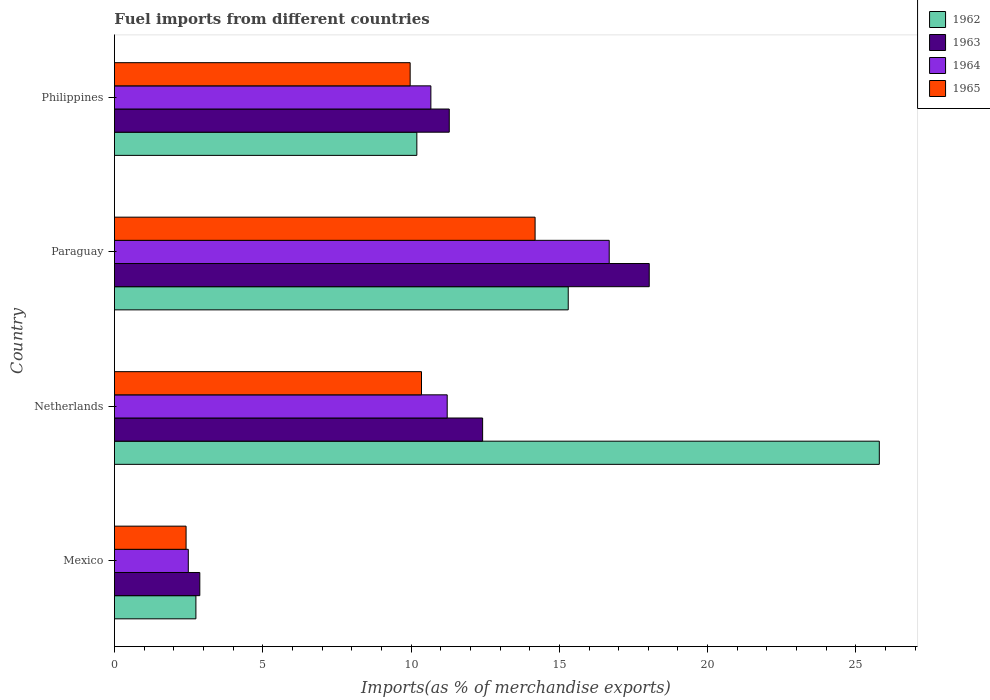Are the number of bars on each tick of the Y-axis equal?
Make the answer very short. Yes. How many bars are there on the 3rd tick from the bottom?
Provide a short and direct response. 4. What is the percentage of imports to different countries in 1965 in Philippines?
Offer a terse response. 9.97. Across all countries, what is the maximum percentage of imports to different countries in 1964?
Make the answer very short. 16.68. Across all countries, what is the minimum percentage of imports to different countries in 1962?
Your response must be concise. 2.75. In which country was the percentage of imports to different countries in 1964 maximum?
Offer a very short reply. Paraguay. In which country was the percentage of imports to different countries in 1962 minimum?
Provide a short and direct response. Mexico. What is the total percentage of imports to different countries in 1963 in the graph?
Your response must be concise. 44.61. What is the difference between the percentage of imports to different countries in 1965 in Netherlands and that in Paraguay?
Your answer should be compact. -3.83. What is the difference between the percentage of imports to different countries in 1964 in Paraguay and the percentage of imports to different countries in 1965 in Netherlands?
Give a very brief answer. 6.33. What is the average percentage of imports to different countries in 1963 per country?
Offer a very short reply. 11.15. What is the difference between the percentage of imports to different countries in 1965 and percentage of imports to different countries in 1962 in Philippines?
Give a very brief answer. -0.23. What is the ratio of the percentage of imports to different countries in 1965 in Paraguay to that in Philippines?
Provide a succinct answer. 1.42. Is the percentage of imports to different countries in 1965 in Mexico less than that in Paraguay?
Your response must be concise. Yes. Is the difference between the percentage of imports to different countries in 1965 in Paraguay and Philippines greater than the difference between the percentage of imports to different countries in 1962 in Paraguay and Philippines?
Provide a short and direct response. No. What is the difference between the highest and the second highest percentage of imports to different countries in 1963?
Your answer should be very brief. 5.62. What is the difference between the highest and the lowest percentage of imports to different countries in 1962?
Your response must be concise. 23.04. Is the sum of the percentage of imports to different countries in 1962 in Netherlands and Philippines greater than the maximum percentage of imports to different countries in 1965 across all countries?
Your answer should be very brief. Yes. What does the 1st bar from the bottom in Philippines represents?
Keep it short and to the point. 1962. How many bars are there?
Give a very brief answer. 16. How many countries are there in the graph?
Provide a short and direct response. 4. What is the difference between two consecutive major ticks on the X-axis?
Provide a short and direct response. 5. Are the values on the major ticks of X-axis written in scientific E-notation?
Keep it short and to the point. No. Does the graph contain any zero values?
Ensure brevity in your answer.  No. Where does the legend appear in the graph?
Provide a succinct answer. Top right. How many legend labels are there?
Offer a terse response. 4. How are the legend labels stacked?
Provide a succinct answer. Vertical. What is the title of the graph?
Ensure brevity in your answer.  Fuel imports from different countries. Does "1997" appear as one of the legend labels in the graph?
Make the answer very short. No. What is the label or title of the X-axis?
Give a very brief answer. Imports(as % of merchandise exports). What is the label or title of the Y-axis?
Your response must be concise. Country. What is the Imports(as % of merchandise exports) of 1962 in Mexico?
Provide a succinct answer. 2.75. What is the Imports(as % of merchandise exports) in 1963 in Mexico?
Provide a succinct answer. 2.88. What is the Imports(as % of merchandise exports) of 1964 in Mexico?
Your response must be concise. 2.49. What is the Imports(as % of merchandise exports) in 1965 in Mexico?
Provide a succinct answer. 2.42. What is the Imports(as % of merchandise exports) of 1962 in Netherlands?
Keep it short and to the point. 25.79. What is the Imports(as % of merchandise exports) in 1963 in Netherlands?
Provide a succinct answer. 12.41. What is the Imports(as % of merchandise exports) in 1964 in Netherlands?
Offer a very short reply. 11.22. What is the Imports(as % of merchandise exports) in 1965 in Netherlands?
Offer a very short reply. 10.35. What is the Imports(as % of merchandise exports) in 1962 in Paraguay?
Give a very brief answer. 15.3. What is the Imports(as % of merchandise exports) in 1963 in Paraguay?
Your answer should be very brief. 18.03. What is the Imports(as % of merchandise exports) in 1964 in Paraguay?
Your answer should be compact. 16.68. What is the Imports(as % of merchandise exports) of 1965 in Paraguay?
Provide a short and direct response. 14.18. What is the Imports(as % of merchandise exports) of 1962 in Philippines?
Ensure brevity in your answer.  10.2. What is the Imports(as % of merchandise exports) of 1963 in Philippines?
Keep it short and to the point. 11.29. What is the Imports(as % of merchandise exports) in 1964 in Philippines?
Keep it short and to the point. 10.67. What is the Imports(as % of merchandise exports) in 1965 in Philippines?
Keep it short and to the point. 9.97. Across all countries, what is the maximum Imports(as % of merchandise exports) in 1962?
Offer a very short reply. 25.79. Across all countries, what is the maximum Imports(as % of merchandise exports) of 1963?
Keep it short and to the point. 18.03. Across all countries, what is the maximum Imports(as % of merchandise exports) in 1964?
Offer a very short reply. 16.68. Across all countries, what is the maximum Imports(as % of merchandise exports) in 1965?
Offer a terse response. 14.18. Across all countries, what is the minimum Imports(as % of merchandise exports) in 1962?
Keep it short and to the point. 2.75. Across all countries, what is the minimum Imports(as % of merchandise exports) of 1963?
Your answer should be very brief. 2.88. Across all countries, what is the minimum Imports(as % of merchandise exports) in 1964?
Ensure brevity in your answer.  2.49. Across all countries, what is the minimum Imports(as % of merchandise exports) in 1965?
Offer a terse response. 2.42. What is the total Imports(as % of merchandise exports) in 1962 in the graph?
Ensure brevity in your answer.  54.03. What is the total Imports(as % of merchandise exports) of 1963 in the graph?
Your answer should be compact. 44.61. What is the total Imports(as % of merchandise exports) in 1964 in the graph?
Your answer should be very brief. 41.06. What is the total Imports(as % of merchandise exports) in 1965 in the graph?
Offer a very short reply. 36.92. What is the difference between the Imports(as % of merchandise exports) in 1962 in Mexico and that in Netherlands?
Offer a terse response. -23.04. What is the difference between the Imports(as % of merchandise exports) in 1963 in Mexico and that in Netherlands?
Make the answer very short. -9.53. What is the difference between the Imports(as % of merchandise exports) in 1964 in Mexico and that in Netherlands?
Your answer should be very brief. -8.73. What is the difference between the Imports(as % of merchandise exports) in 1965 in Mexico and that in Netherlands?
Offer a very short reply. -7.94. What is the difference between the Imports(as % of merchandise exports) in 1962 in Mexico and that in Paraguay?
Keep it short and to the point. -12.55. What is the difference between the Imports(as % of merchandise exports) in 1963 in Mexico and that in Paraguay?
Give a very brief answer. -15.15. What is the difference between the Imports(as % of merchandise exports) in 1964 in Mexico and that in Paraguay?
Your answer should be compact. -14.19. What is the difference between the Imports(as % of merchandise exports) in 1965 in Mexico and that in Paraguay?
Your response must be concise. -11.77. What is the difference between the Imports(as % of merchandise exports) of 1962 in Mexico and that in Philippines?
Provide a short and direct response. -7.45. What is the difference between the Imports(as % of merchandise exports) of 1963 in Mexico and that in Philippines?
Provide a succinct answer. -8.41. What is the difference between the Imports(as % of merchandise exports) in 1964 in Mexico and that in Philippines?
Provide a short and direct response. -8.18. What is the difference between the Imports(as % of merchandise exports) in 1965 in Mexico and that in Philippines?
Your answer should be very brief. -7.55. What is the difference between the Imports(as % of merchandise exports) in 1962 in Netherlands and that in Paraguay?
Provide a short and direct response. 10.49. What is the difference between the Imports(as % of merchandise exports) of 1963 in Netherlands and that in Paraguay?
Offer a very short reply. -5.62. What is the difference between the Imports(as % of merchandise exports) of 1964 in Netherlands and that in Paraguay?
Your answer should be compact. -5.46. What is the difference between the Imports(as % of merchandise exports) in 1965 in Netherlands and that in Paraguay?
Make the answer very short. -3.83. What is the difference between the Imports(as % of merchandise exports) in 1962 in Netherlands and that in Philippines?
Ensure brevity in your answer.  15.59. What is the difference between the Imports(as % of merchandise exports) of 1963 in Netherlands and that in Philippines?
Your answer should be very brief. 1.12. What is the difference between the Imports(as % of merchandise exports) of 1964 in Netherlands and that in Philippines?
Provide a succinct answer. 0.55. What is the difference between the Imports(as % of merchandise exports) of 1965 in Netherlands and that in Philippines?
Your response must be concise. 0.38. What is the difference between the Imports(as % of merchandise exports) of 1962 in Paraguay and that in Philippines?
Ensure brevity in your answer.  5.1. What is the difference between the Imports(as % of merchandise exports) of 1963 in Paraguay and that in Philippines?
Your response must be concise. 6.74. What is the difference between the Imports(as % of merchandise exports) of 1964 in Paraguay and that in Philippines?
Your response must be concise. 6.01. What is the difference between the Imports(as % of merchandise exports) of 1965 in Paraguay and that in Philippines?
Offer a terse response. 4.21. What is the difference between the Imports(as % of merchandise exports) in 1962 in Mexico and the Imports(as % of merchandise exports) in 1963 in Netherlands?
Ensure brevity in your answer.  -9.67. What is the difference between the Imports(as % of merchandise exports) of 1962 in Mexico and the Imports(as % of merchandise exports) of 1964 in Netherlands?
Your answer should be compact. -8.47. What is the difference between the Imports(as % of merchandise exports) of 1962 in Mexico and the Imports(as % of merchandise exports) of 1965 in Netherlands?
Keep it short and to the point. -7.61. What is the difference between the Imports(as % of merchandise exports) of 1963 in Mexico and the Imports(as % of merchandise exports) of 1964 in Netherlands?
Your response must be concise. -8.34. What is the difference between the Imports(as % of merchandise exports) in 1963 in Mexico and the Imports(as % of merchandise exports) in 1965 in Netherlands?
Make the answer very short. -7.47. What is the difference between the Imports(as % of merchandise exports) in 1964 in Mexico and the Imports(as % of merchandise exports) in 1965 in Netherlands?
Give a very brief answer. -7.86. What is the difference between the Imports(as % of merchandise exports) of 1962 in Mexico and the Imports(as % of merchandise exports) of 1963 in Paraguay?
Your response must be concise. -15.28. What is the difference between the Imports(as % of merchandise exports) of 1962 in Mexico and the Imports(as % of merchandise exports) of 1964 in Paraguay?
Offer a very short reply. -13.93. What is the difference between the Imports(as % of merchandise exports) in 1962 in Mexico and the Imports(as % of merchandise exports) in 1965 in Paraguay?
Give a very brief answer. -11.44. What is the difference between the Imports(as % of merchandise exports) of 1963 in Mexico and the Imports(as % of merchandise exports) of 1964 in Paraguay?
Your answer should be very brief. -13.8. What is the difference between the Imports(as % of merchandise exports) in 1963 in Mexico and the Imports(as % of merchandise exports) in 1965 in Paraguay?
Give a very brief answer. -11.3. What is the difference between the Imports(as % of merchandise exports) in 1964 in Mexico and the Imports(as % of merchandise exports) in 1965 in Paraguay?
Your answer should be compact. -11.69. What is the difference between the Imports(as % of merchandise exports) of 1962 in Mexico and the Imports(as % of merchandise exports) of 1963 in Philippines?
Provide a succinct answer. -8.54. What is the difference between the Imports(as % of merchandise exports) of 1962 in Mexico and the Imports(as % of merchandise exports) of 1964 in Philippines?
Offer a terse response. -7.92. What is the difference between the Imports(as % of merchandise exports) in 1962 in Mexico and the Imports(as % of merchandise exports) in 1965 in Philippines?
Offer a terse response. -7.22. What is the difference between the Imports(as % of merchandise exports) of 1963 in Mexico and the Imports(as % of merchandise exports) of 1964 in Philippines?
Your answer should be very brief. -7.79. What is the difference between the Imports(as % of merchandise exports) in 1963 in Mexico and the Imports(as % of merchandise exports) in 1965 in Philippines?
Provide a succinct answer. -7.09. What is the difference between the Imports(as % of merchandise exports) in 1964 in Mexico and the Imports(as % of merchandise exports) in 1965 in Philippines?
Provide a short and direct response. -7.48. What is the difference between the Imports(as % of merchandise exports) in 1962 in Netherlands and the Imports(as % of merchandise exports) in 1963 in Paraguay?
Keep it short and to the point. 7.76. What is the difference between the Imports(as % of merchandise exports) of 1962 in Netherlands and the Imports(as % of merchandise exports) of 1964 in Paraguay?
Provide a succinct answer. 9.11. What is the difference between the Imports(as % of merchandise exports) of 1962 in Netherlands and the Imports(as % of merchandise exports) of 1965 in Paraguay?
Your answer should be very brief. 11.6. What is the difference between the Imports(as % of merchandise exports) in 1963 in Netherlands and the Imports(as % of merchandise exports) in 1964 in Paraguay?
Your answer should be compact. -4.27. What is the difference between the Imports(as % of merchandise exports) in 1963 in Netherlands and the Imports(as % of merchandise exports) in 1965 in Paraguay?
Offer a very short reply. -1.77. What is the difference between the Imports(as % of merchandise exports) of 1964 in Netherlands and the Imports(as % of merchandise exports) of 1965 in Paraguay?
Ensure brevity in your answer.  -2.96. What is the difference between the Imports(as % of merchandise exports) of 1962 in Netherlands and the Imports(as % of merchandise exports) of 1963 in Philippines?
Provide a succinct answer. 14.5. What is the difference between the Imports(as % of merchandise exports) in 1962 in Netherlands and the Imports(as % of merchandise exports) in 1964 in Philippines?
Provide a succinct answer. 15.12. What is the difference between the Imports(as % of merchandise exports) in 1962 in Netherlands and the Imports(as % of merchandise exports) in 1965 in Philippines?
Keep it short and to the point. 15.82. What is the difference between the Imports(as % of merchandise exports) in 1963 in Netherlands and the Imports(as % of merchandise exports) in 1964 in Philippines?
Give a very brief answer. 1.74. What is the difference between the Imports(as % of merchandise exports) in 1963 in Netherlands and the Imports(as % of merchandise exports) in 1965 in Philippines?
Offer a terse response. 2.44. What is the difference between the Imports(as % of merchandise exports) in 1964 in Netherlands and the Imports(as % of merchandise exports) in 1965 in Philippines?
Your answer should be compact. 1.25. What is the difference between the Imports(as % of merchandise exports) in 1962 in Paraguay and the Imports(as % of merchandise exports) in 1963 in Philippines?
Your answer should be compact. 4.01. What is the difference between the Imports(as % of merchandise exports) of 1962 in Paraguay and the Imports(as % of merchandise exports) of 1964 in Philippines?
Your answer should be very brief. 4.63. What is the difference between the Imports(as % of merchandise exports) in 1962 in Paraguay and the Imports(as % of merchandise exports) in 1965 in Philippines?
Make the answer very short. 5.33. What is the difference between the Imports(as % of merchandise exports) of 1963 in Paraguay and the Imports(as % of merchandise exports) of 1964 in Philippines?
Provide a succinct answer. 7.36. What is the difference between the Imports(as % of merchandise exports) in 1963 in Paraguay and the Imports(as % of merchandise exports) in 1965 in Philippines?
Offer a very short reply. 8.06. What is the difference between the Imports(as % of merchandise exports) of 1964 in Paraguay and the Imports(as % of merchandise exports) of 1965 in Philippines?
Ensure brevity in your answer.  6.71. What is the average Imports(as % of merchandise exports) of 1962 per country?
Ensure brevity in your answer.  13.51. What is the average Imports(as % of merchandise exports) in 1963 per country?
Offer a very short reply. 11.15. What is the average Imports(as % of merchandise exports) of 1964 per country?
Give a very brief answer. 10.26. What is the average Imports(as % of merchandise exports) of 1965 per country?
Offer a terse response. 9.23. What is the difference between the Imports(as % of merchandise exports) of 1962 and Imports(as % of merchandise exports) of 1963 in Mexico?
Your response must be concise. -0.13. What is the difference between the Imports(as % of merchandise exports) of 1962 and Imports(as % of merchandise exports) of 1964 in Mexico?
Make the answer very short. 0.26. What is the difference between the Imports(as % of merchandise exports) in 1962 and Imports(as % of merchandise exports) in 1965 in Mexico?
Provide a short and direct response. 0.33. What is the difference between the Imports(as % of merchandise exports) of 1963 and Imports(as % of merchandise exports) of 1964 in Mexico?
Your answer should be compact. 0.39. What is the difference between the Imports(as % of merchandise exports) of 1963 and Imports(as % of merchandise exports) of 1965 in Mexico?
Ensure brevity in your answer.  0.46. What is the difference between the Imports(as % of merchandise exports) in 1964 and Imports(as % of merchandise exports) in 1965 in Mexico?
Make the answer very short. 0.07. What is the difference between the Imports(as % of merchandise exports) in 1962 and Imports(as % of merchandise exports) in 1963 in Netherlands?
Provide a succinct answer. 13.37. What is the difference between the Imports(as % of merchandise exports) of 1962 and Imports(as % of merchandise exports) of 1964 in Netherlands?
Keep it short and to the point. 14.57. What is the difference between the Imports(as % of merchandise exports) in 1962 and Imports(as % of merchandise exports) in 1965 in Netherlands?
Make the answer very short. 15.43. What is the difference between the Imports(as % of merchandise exports) of 1963 and Imports(as % of merchandise exports) of 1964 in Netherlands?
Provide a succinct answer. 1.19. What is the difference between the Imports(as % of merchandise exports) of 1963 and Imports(as % of merchandise exports) of 1965 in Netherlands?
Give a very brief answer. 2.06. What is the difference between the Imports(as % of merchandise exports) of 1964 and Imports(as % of merchandise exports) of 1965 in Netherlands?
Offer a terse response. 0.87. What is the difference between the Imports(as % of merchandise exports) of 1962 and Imports(as % of merchandise exports) of 1963 in Paraguay?
Your answer should be very brief. -2.73. What is the difference between the Imports(as % of merchandise exports) in 1962 and Imports(as % of merchandise exports) in 1964 in Paraguay?
Your answer should be very brief. -1.38. What is the difference between the Imports(as % of merchandise exports) of 1962 and Imports(as % of merchandise exports) of 1965 in Paraguay?
Your answer should be very brief. 1.12. What is the difference between the Imports(as % of merchandise exports) of 1963 and Imports(as % of merchandise exports) of 1964 in Paraguay?
Offer a very short reply. 1.35. What is the difference between the Imports(as % of merchandise exports) in 1963 and Imports(as % of merchandise exports) in 1965 in Paraguay?
Provide a succinct answer. 3.85. What is the difference between the Imports(as % of merchandise exports) in 1964 and Imports(as % of merchandise exports) in 1965 in Paraguay?
Offer a terse response. 2.5. What is the difference between the Imports(as % of merchandise exports) of 1962 and Imports(as % of merchandise exports) of 1963 in Philippines?
Your response must be concise. -1.09. What is the difference between the Imports(as % of merchandise exports) in 1962 and Imports(as % of merchandise exports) in 1964 in Philippines?
Your answer should be very brief. -0.47. What is the difference between the Imports(as % of merchandise exports) of 1962 and Imports(as % of merchandise exports) of 1965 in Philippines?
Your answer should be very brief. 0.23. What is the difference between the Imports(as % of merchandise exports) in 1963 and Imports(as % of merchandise exports) in 1964 in Philippines?
Offer a very short reply. 0.62. What is the difference between the Imports(as % of merchandise exports) in 1963 and Imports(as % of merchandise exports) in 1965 in Philippines?
Your answer should be compact. 1.32. What is the difference between the Imports(as % of merchandise exports) in 1964 and Imports(as % of merchandise exports) in 1965 in Philippines?
Your response must be concise. 0.7. What is the ratio of the Imports(as % of merchandise exports) of 1962 in Mexico to that in Netherlands?
Offer a very short reply. 0.11. What is the ratio of the Imports(as % of merchandise exports) in 1963 in Mexico to that in Netherlands?
Your answer should be compact. 0.23. What is the ratio of the Imports(as % of merchandise exports) in 1964 in Mexico to that in Netherlands?
Make the answer very short. 0.22. What is the ratio of the Imports(as % of merchandise exports) in 1965 in Mexico to that in Netherlands?
Your response must be concise. 0.23. What is the ratio of the Imports(as % of merchandise exports) of 1962 in Mexico to that in Paraguay?
Ensure brevity in your answer.  0.18. What is the ratio of the Imports(as % of merchandise exports) in 1963 in Mexico to that in Paraguay?
Provide a short and direct response. 0.16. What is the ratio of the Imports(as % of merchandise exports) in 1964 in Mexico to that in Paraguay?
Your answer should be compact. 0.15. What is the ratio of the Imports(as % of merchandise exports) in 1965 in Mexico to that in Paraguay?
Your response must be concise. 0.17. What is the ratio of the Imports(as % of merchandise exports) in 1962 in Mexico to that in Philippines?
Offer a terse response. 0.27. What is the ratio of the Imports(as % of merchandise exports) in 1963 in Mexico to that in Philippines?
Provide a succinct answer. 0.26. What is the ratio of the Imports(as % of merchandise exports) of 1964 in Mexico to that in Philippines?
Provide a short and direct response. 0.23. What is the ratio of the Imports(as % of merchandise exports) in 1965 in Mexico to that in Philippines?
Give a very brief answer. 0.24. What is the ratio of the Imports(as % of merchandise exports) in 1962 in Netherlands to that in Paraguay?
Your answer should be very brief. 1.69. What is the ratio of the Imports(as % of merchandise exports) in 1963 in Netherlands to that in Paraguay?
Your response must be concise. 0.69. What is the ratio of the Imports(as % of merchandise exports) of 1964 in Netherlands to that in Paraguay?
Ensure brevity in your answer.  0.67. What is the ratio of the Imports(as % of merchandise exports) in 1965 in Netherlands to that in Paraguay?
Your response must be concise. 0.73. What is the ratio of the Imports(as % of merchandise exports) in 1962 in Netherlands to that in Philippines?
Your answer should be very brief. 2.53. What is the ratio of the Imports(as % of merchandise exports) in 1963 in Netherlands to that in Philippines?
Give a very brief answer. 1.1. What is the ratio of the Imports(as % of merchandise exports) in 1964 in Netherlands to that in Philippines?
Provide a succinct answer. 1.05. What is the ratio of the Imports(as % of merchandise exports) of 1965 in Netherlands to that in Philippines?
Offer a terse response. 1.04. What is the ratio of the Imports(as % of merchandise exports) in 1962 in Paraguay to that in Philippines?
Offer a terse response. 1.5. What is the ratio of the Imports(as % of merchandise exports) of 1963 in Paraguay to that in Philippines?
Offer a very short reply. 1.6. What is the ratio of the Imports(as % of merchandise exports) in 1964 in Paraguay to that in Philippines?
Your answer should be very brief. 1.56. What is the ratio of the Imports(as % of merchandise exports) in 1965 in Paraguay to that in Philippines?
Keep it short and to the point. 1.42. What is the difference between the highest and the second highest Imports(as % of merchandise exports) in 1962?
Your answer should be very brief. 10.49. What is the difference between the highest and the second highest Imports(as % of merchandise exports) of 1963?
Ensure brevity in your answer.  5.62. What is the difference between the highest and the second highest Imports(as % of merchandise exports) of 1964?
Provide a succinct answer. 5.46. What is the difference between the highest and the second highest Imports(as % of merchandise exports) of 1965?
Your answer should be compact. 3.83. What is the difference between the highest and the lowest Imports(as % of merchandise exports) of 1962?
Ensure brevity in your answer.  23.04. What is the difference between the highest and the lowest Imports(as % of merchandise exports) of 1963?
Keep it short and to the point. 15.15. What is the difference between the highest and the lowest Imports(as % of merchandise exports) in 1964?
Ensure brevity in your answer.  14.19. What is the difference between the highest and the lowest Imports(as % of merchandise exports) in 1965?
Give a very brief answer. 11.77. 